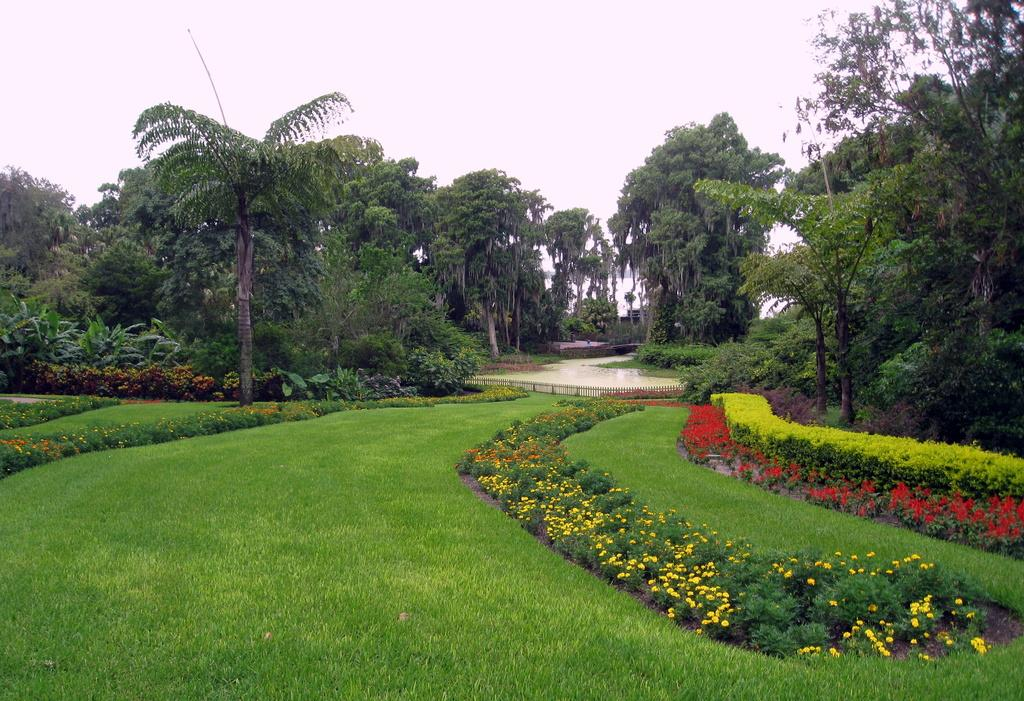What type of ground cover is present in the image? There is green grass on the ground in the image. What other types of vegetation can be seen in the image? There are plants and trees in the image. What is visible at the top of the image? The sky is visible at the top of the image. How many elbows can be seen in the image? There are no elbows present in the image, as it features natural elements like grass, plants, trees, and the sky. 